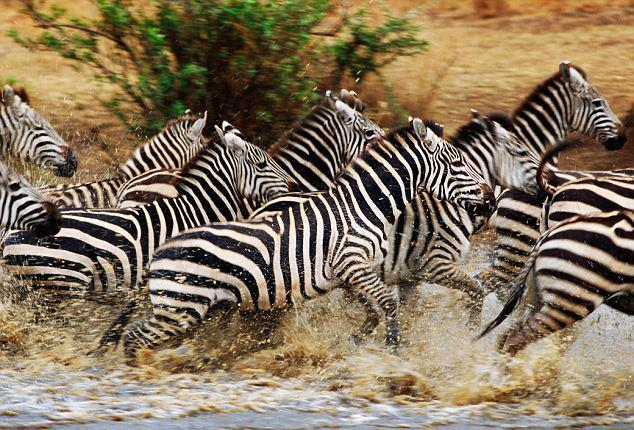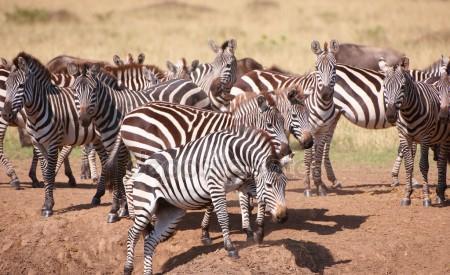The first image is the image on the left, the second image is the image on the right. For the images shown, is this caption "One image shows a herd of zebras in profile all moving toward the right and stirring up the non-grass material under their feet." true? Answer yes or no. Yes. The first image is the image on the left, the second image is the image on the right. Given the left and right images, does the statement "One animal in one of the images is bucking." hold true? Answer yes or no. Yes. 